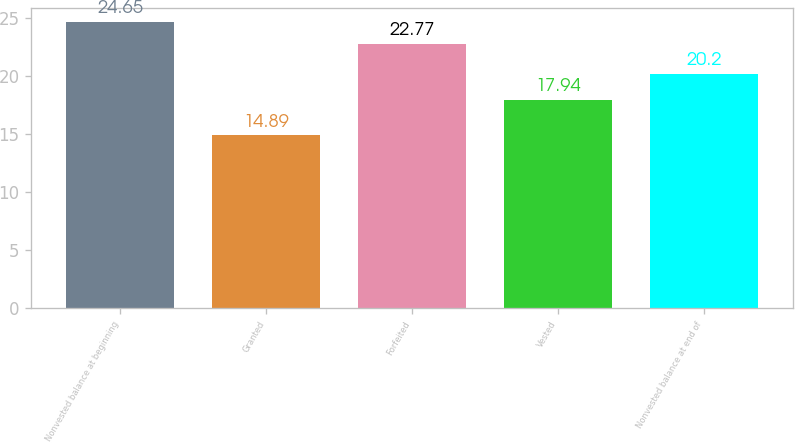Convert chart to OTSL. <chart><loc_0><loc_0><loc_500><loc_500><bar_chart><fcel>Nonvested balance at beginning<fcel>Granted<fcel>Forfeited<fcel>Vested<fcel>Nonvested balance at end of<nl><fcel>24.65<fcel>14.89<fcel>22.77<fcel>17.94<fcel>20.2<nl></chart> 